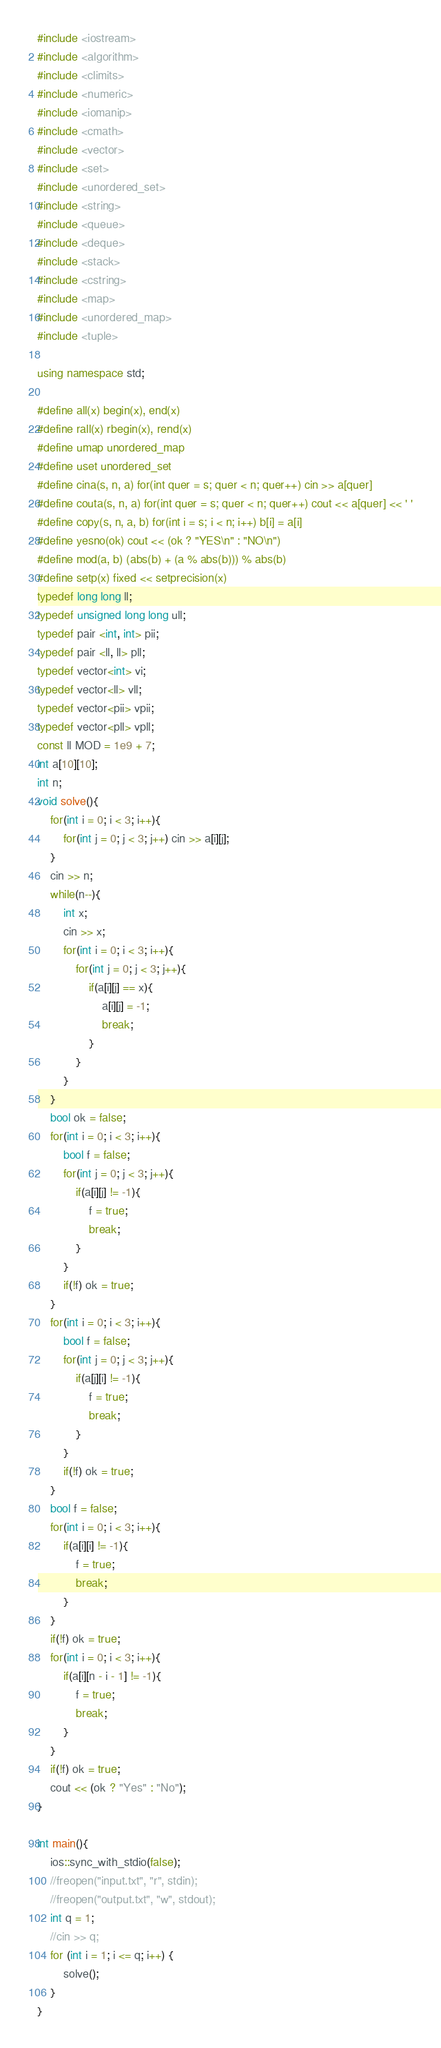<code> <loc_0><loc_0><loc_500><loc_500><_C++_>#include <iostream>
#include <algorithm>
#include <climits>
#include <numeric>
#include <iomanip>
#include <cmath>
#include <vector>
#include <set>
#include <unordered_set>
#include <string>
#include <queue>
#include <deque>
#include <stack>
#include <cstring>
#include <map>
#include <unordered_map>
#include <tuple>

using namespace std;

#define all(x) begin(x), end(x)
#define rall(x) rbegin(x), rend(x)
#define umap unordered_map
#define uset unordered_set
#define cina(s, n, a) for(int quer = s; quer < n; quer++) cin >> a[quer]
#define couta(s, n, a) for(int quer = s; quer < n; quer++) cout << a[quer] << ' '
#define copy(s, n, a, b) for(int i = s; i < n; i++) b[i] = a[i]
#define yesno(ok) cout << (ok ? "YES\n" : "NO\n")
#define mod(a, b) (abs(b) + (a % abs(b))) % abs(b)
#define setp(x) fixed << setprecision(x)
typedef long long ll;
typedef unsigned long long ull;
typedef pair <int, int> pii;
typedef pair <ll, ll> pll;
typedef vector<int> vi;
typedef vector<ll> vll;
typedef vector<pii> vpii;
typedef vector<pll> vpll;
const ll MOD = 1e9 + 7;
int a[10][10];
int n;
void solve(){
    for(int i = 0; i < 3; i++){
        for(int j = 0; j < 3; j++) cin >> a[i][j];
    }
    cin >> n;
    while(n--){
        int x;
        cin >> x;
        for(int i = 0; i < 3; i++){
            for(int j = 0; j < 3; j++){
                if(a[i][j] == x){
                    a[i][j] = -1;
                    break;
                }
            }
        }
    }
    bool ok = false;
    for(int i = 0; i < 3; i++){
        bool f = false;
        for(int j = 0; j < 3; j++){
            if(a[i][j] != -1){
                f = true;
                break;
            }
        }
        if(!f) ok = true;
    }
    for(int i = 0; i < 3; i++){
        bool f = false;
        for(int j = 0; j < 3; j++){
            if(a[j][i] != -1){
                f = true;
                break;
            }
        }
        if(!f) ok = true;
    }
    bool f = false;
    for(int i = 0; i < 3; i++){
        if(a[i][i] != -1){
            f = true;
            break;
        }
    }
    if(!f) ok = true;
    for(int i = 0; i < 3; i++){
        if(a[i][n - i - 1] != -1){
            f = true;
            break;
        }
    }
    if(!f) ok = true;
    cout << (ok ? "Yes" : "No");
}

int main(){
    ios::sync_with_stdio(false);
    //freopen("input.txt", "r", stdin);
    //freopen("output.txt", "w", stdout);
    int q = 1;
    //cin >> q;
    for (int i = 1; i <= q; i++) {
        solve();
    }
}
</code> 